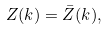<formula> <loc_0><loc_0><loc_500><loc_500>Z ( k ) = \bar { Z } ( k ) ,</formula> 